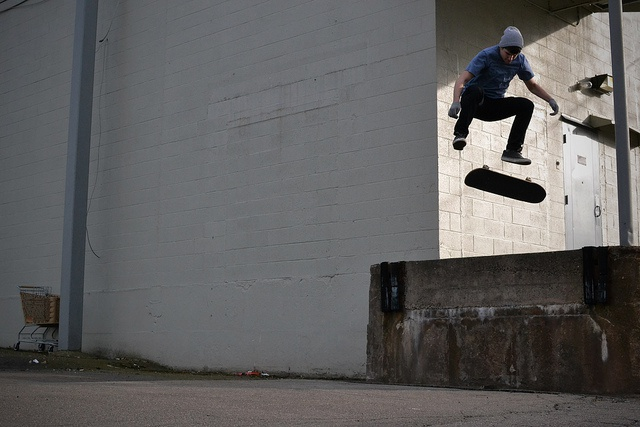Describe the objects in this image and their specific colors. I can see people in black, gray, navy, and darkgray tones and skateboard in black, gray, darkgray, and lightgray tones in this image. 